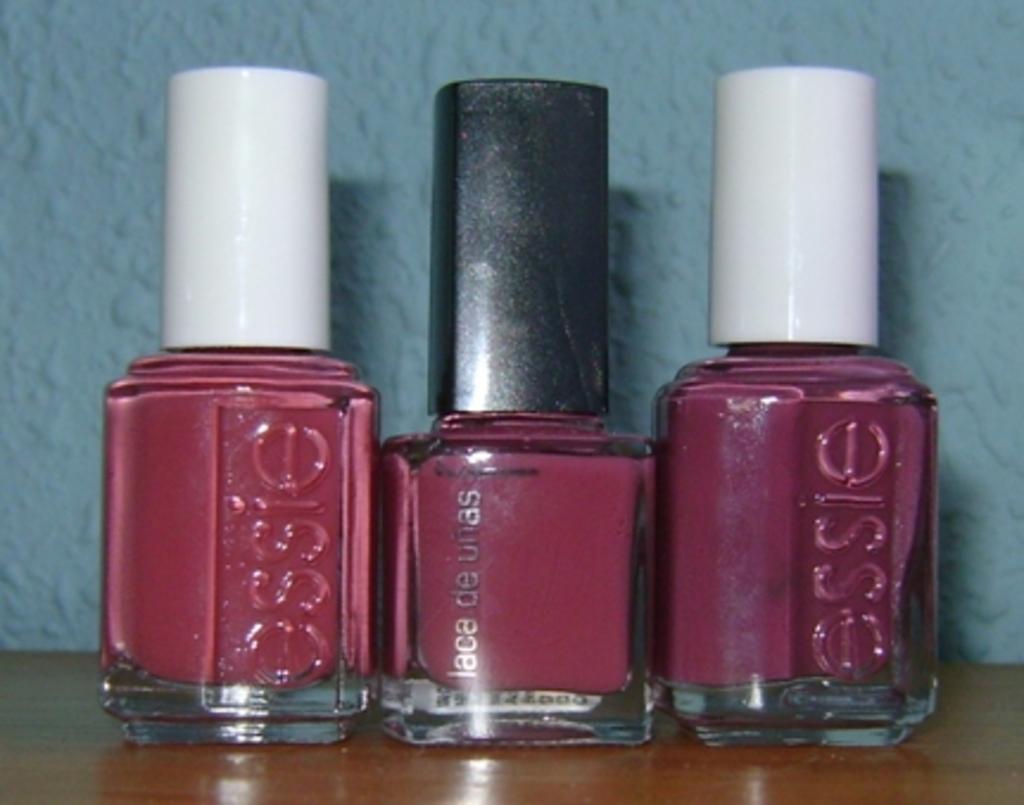Can you describe this image briefly? In this image we can see some nail polish containers which are placed on the table. On the backside we can see a wall. 